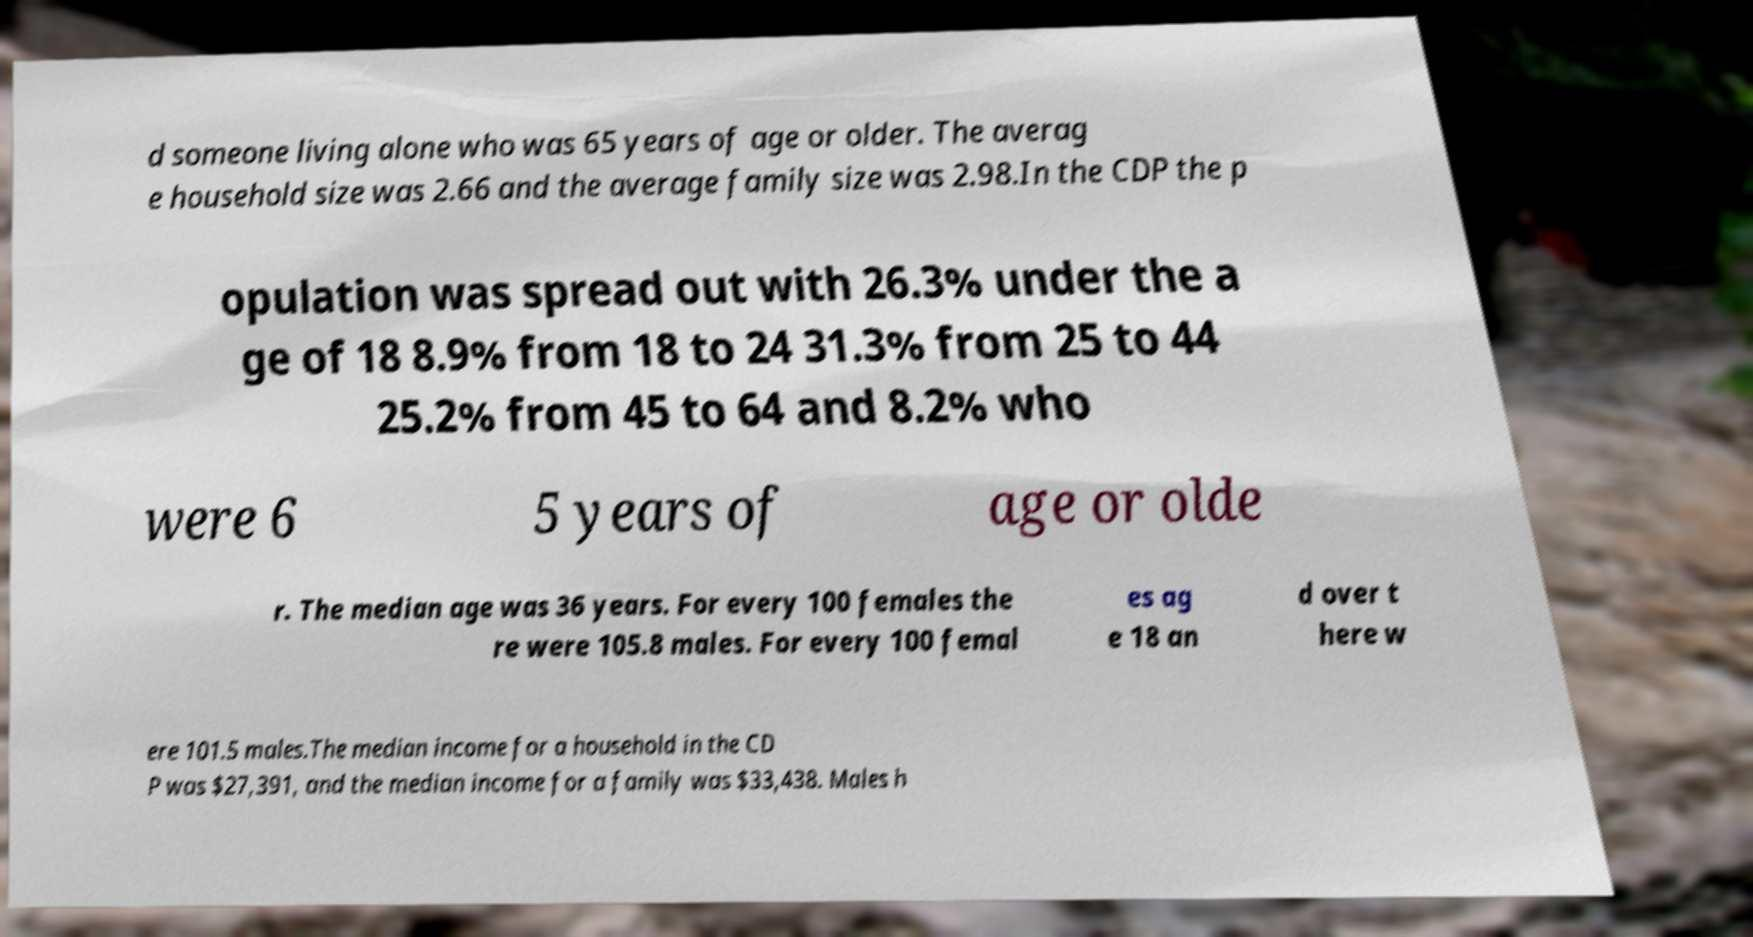Could you assist in decoding the text presented in this image and type it out clearly? d someone living alone who was 65 years of age or older. The averag e household size was 2.66 and the average family size was 2.98.In the CDP the p opulation was spread out with 26.3% under the a ge of 18 8.9% from 18 to 24 31.3% from 25 to 44 25.2% from 45 to 64 and 8.2% who were 6 5 years of age or olde r. The median age was 36 years. For every 100 females the re were 105.8 males. For every 100 femal es ag e 18 an d over t here w ere 101.5 males.The median income for a household in the CD P was $27,391, and the median income for a family was $33,438. Males h 